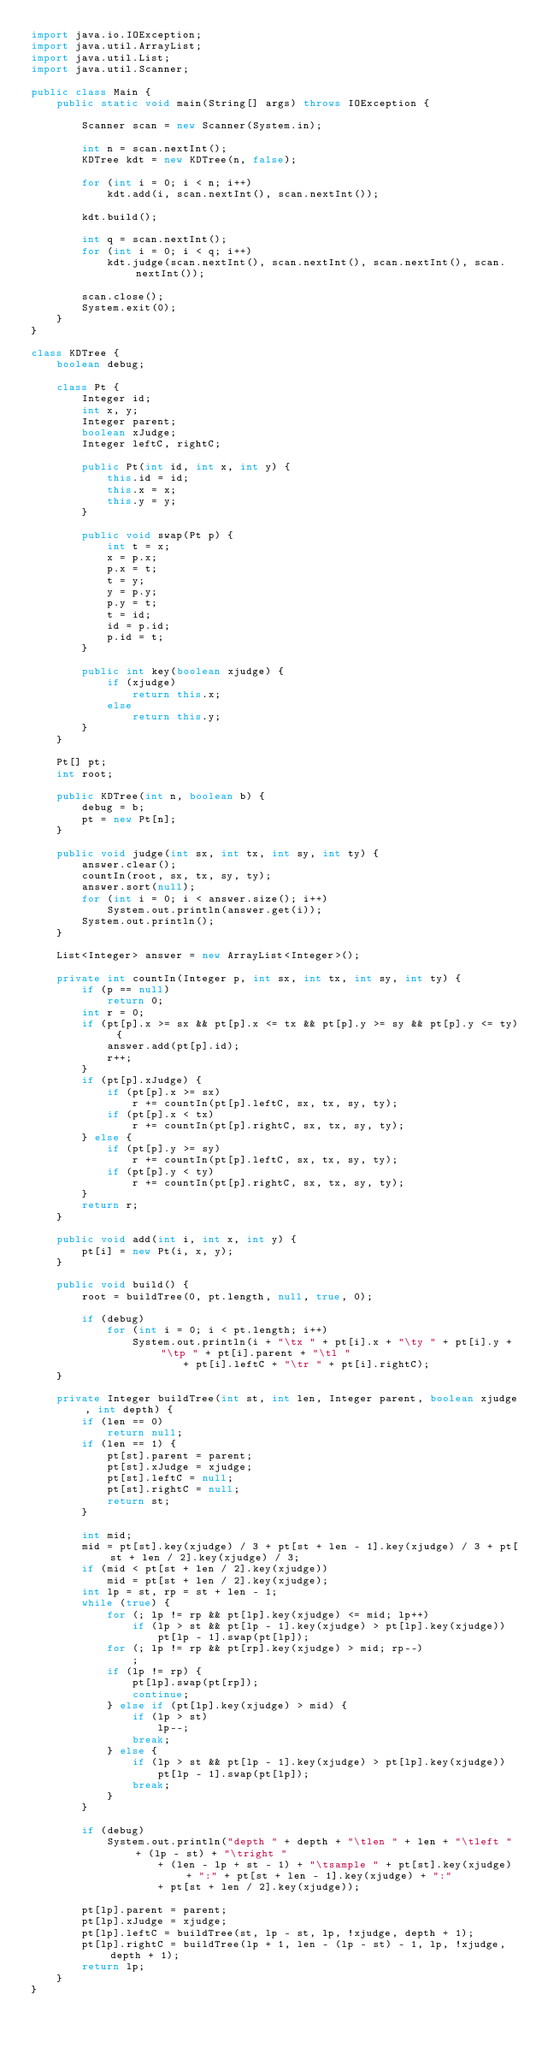Convert code to text. <code><loc_0><loc_0><loc_500><loc_500><_Java_>import java.io.IOException;
import java.util.ArrayList;
import java.util.List;
import java.util.Scanner;

public class Main {
	public static void main(String[] args) throws IOException {

		Scanner scan = new Scanner(System.in);

		int n = scan.nextInt();
		KDTree kdt = new KDTree(n, false);

		for (int i = 0; i < n; i++)
			kdt.add(i, scan.nextInt(), scan.nextInt());

		kdt.build();

		int q = scan.nextInt();
		for (int i = 0; i < q; i++)
			kdt.judge(scan.nextInt(), scan.nextInt(), scan.nextInt(), scan.nextInt());

		scan.close();
		System.exit(0);
	}
}

class KDTree {
	boolean debug;

	class Pt {
		Integer id;
		int x, y;
		Integer parent;
		boolean xJudge;
		Integer leftC, rightC;

		public Pt(int id, int x, int y) {
			this.id = id;
			this.x = x;
			this.y = y;
		}

		public void swap(Pt p) {
			int t = x;
			x = p.x;
			p.x = t;
			t = y;
			y = p.y;
			p.y = t;
			t = id;
			id = p.id;
			p.id = t;
		}

		public int key(boolean xjudge) {
			if (xjudge)
				return this.x;
			else
				return this.y;
		}
	}

	Pt[] pt;
	int root;

	public KDTree(int n, boolean b) {
		debug = b;
		pt = new Pt[n];
	}

	public void judge(int sx, int tx, int sy, int ty) {
		answer.clear();
		countIn(root, sx, tx, sy, ty);
		answer.sort(null);
		for (int i = 0; i < answer.size(); i++)
			System.out.println(answer.get(i));
		System.out.println();
	}

	List<Integer> answer = new ArrayList<Integer>();

	private int countIn(Integer p, int sx, int tx, int sy, int ty) {
		if (p == null)
			return 0;
		int r = 0;
		if (pt[p].x >= sx && pt[p].x <= tx && pt[p].y >= sy && pt[p].y <= ty) {
			answer.add(pt[p].id);
			r++;
		}
		if (pt[p].xJudge) {
			if (pt[p].x >= sx)
				r += countIn(pt[p].leftC, sx, tx, sy, ty);
			if (pt[p].x < tx)
				r += countIn(pt[p].rightC, sx, tx, sy, ty);
		} else {
			if (pt[p].y >= sy)
				r += countIn(pt[p].leftC, sx, tx, sy, ty);
			if (pt[p].y < ty)
				r += countIn(pt[p].rightC, sx, tx, sy, ty);
		}
		return r;
	}

	public void add(int i, int x, int y) {
		pt[i] = new Pt(i, x, y);
	}

	public void build() {
		root = buildTree(0, pt.length, null, true, 0);

		if (debug)
			for (int i = 0; i < pt.length; i++)
				System.out.println(i + "\tx " + pt[i].x + "\ty " + pt[i].y + "\tp " + pt[i].parent + "\tl "
						+ pt[i].leftC + "\tr " + pt[i].rightC);
	}

	private Integer buildTree(int st, int len, Integer parent, boolean xjudge, int depth) {
		if (len == 0)
			return null;
		if (len == 1) {
			pt[st].parent = parent;
			pt[st].xJudge = xjudge;
			pt[st].leftC = null;
			pt[st].rightC = null;
			return st;
		}

		int mid;
		mid = pt[st].key(xjudge) / 3 + pt[st + len - 1].key(xjudge) / 3 + pt[st + len / 2].key(xjudge) / 3;
		if (mid < pt[st + len / 2].key(xjudge))
			mid = pt[st + len / 2].key(xjudge);
		int lp = st, rp = st + len - 1;
		while (true) {
			for (; lp != rp && pt[lp].key(xjudge) <= mid; lp++)
				if (lp > st && pt[lp - 1].key(xjudge) > pt[lp].key(xjudge))
					pt[lp - 1].swap(pt[lp]);
			for (; lp != rp && pt[rp].key(xjudge) > mid; rp--)
				;
			if (lp != rp) {
				pt[lp].swap(pt[rp]);
				continue;
			} else if (pt[lp].key(xjudge) > mid) {
				if (lp > st)
					lp--;
				break;
			} else {
				if (lp > st && pt[lp - 1].key(xjudge) > pt[lp].key(xjudge))
					pt[lp - 1].swap(pt[lp]);
				break;
			}
		}

		if (debug)
			System.out.println("depth " + depth + "\tlen " + len + "\tleft " + (lp - st) + "\tright "
					+ (len - lp + st - 1) + "\tsample " + pt[st].key(xjudge) + ":" + pt[st + len - 1].key(xjudge) + ":"
					+ pt[st + len / 2].key(xjudge));

		pt[lp].parent = parent;
		pt[lp].xJudge = xjudge;
		pt[lp].leftC = buildTree(st, lp - st, lp, !xjudge, depth + 1);
		pt[lp].rightC = buildTree(lp + 1, len - (lp - st) - 1, lp, !xjudge, depth + 1);
		return lp;
	}
}</code> 